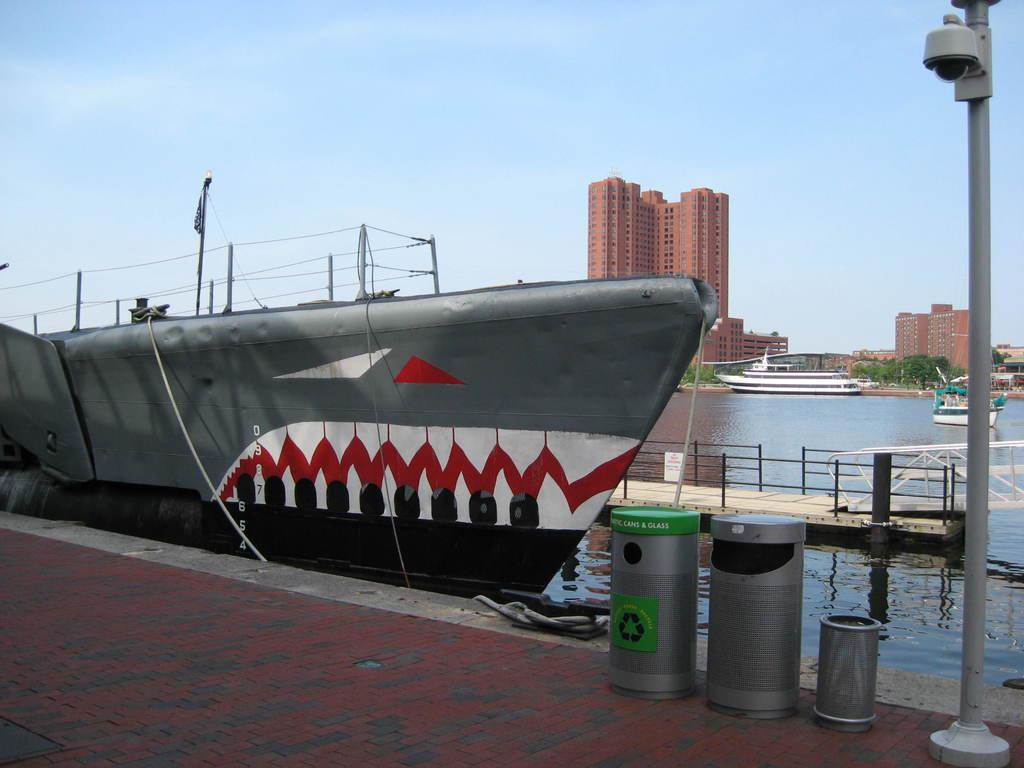<image>
Present a compact description of the photo's key features. a Cans & Glass bin sits in front of a ship painted like a shark 